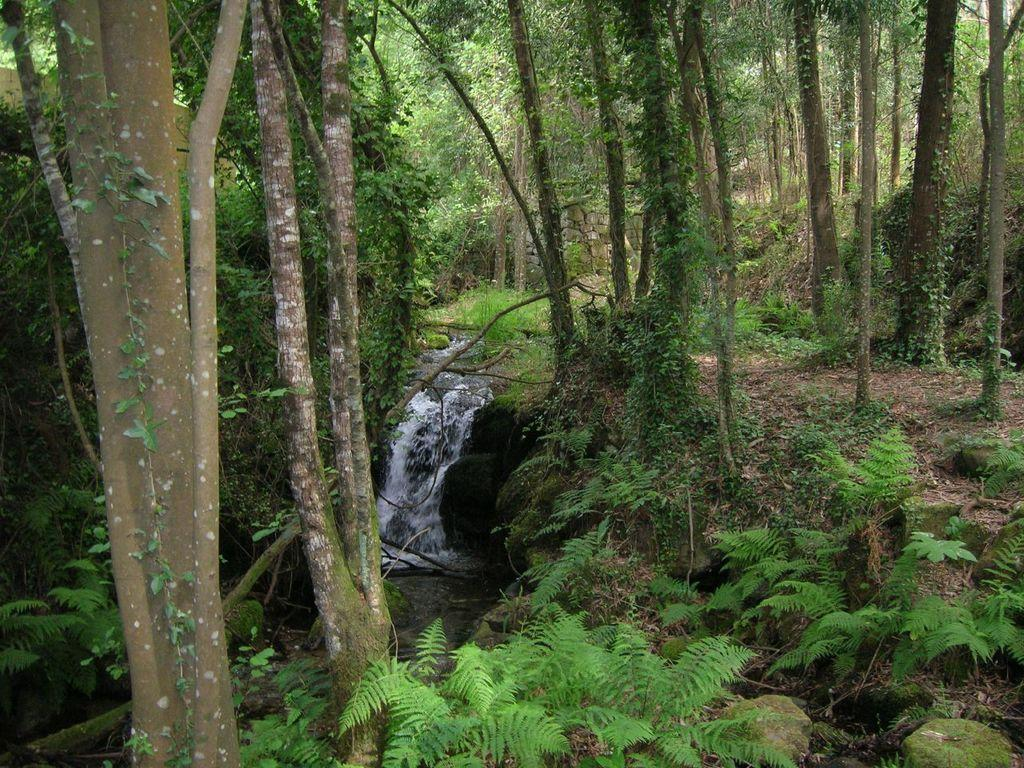What is located in the middle of the image? There is water in the middle of the image. What type of vegetation can be seen in the image? There are trees in the image. What type of orange can be seen hanging from the trees in the image? There are no oranges present in the image; it only features water and trees. 